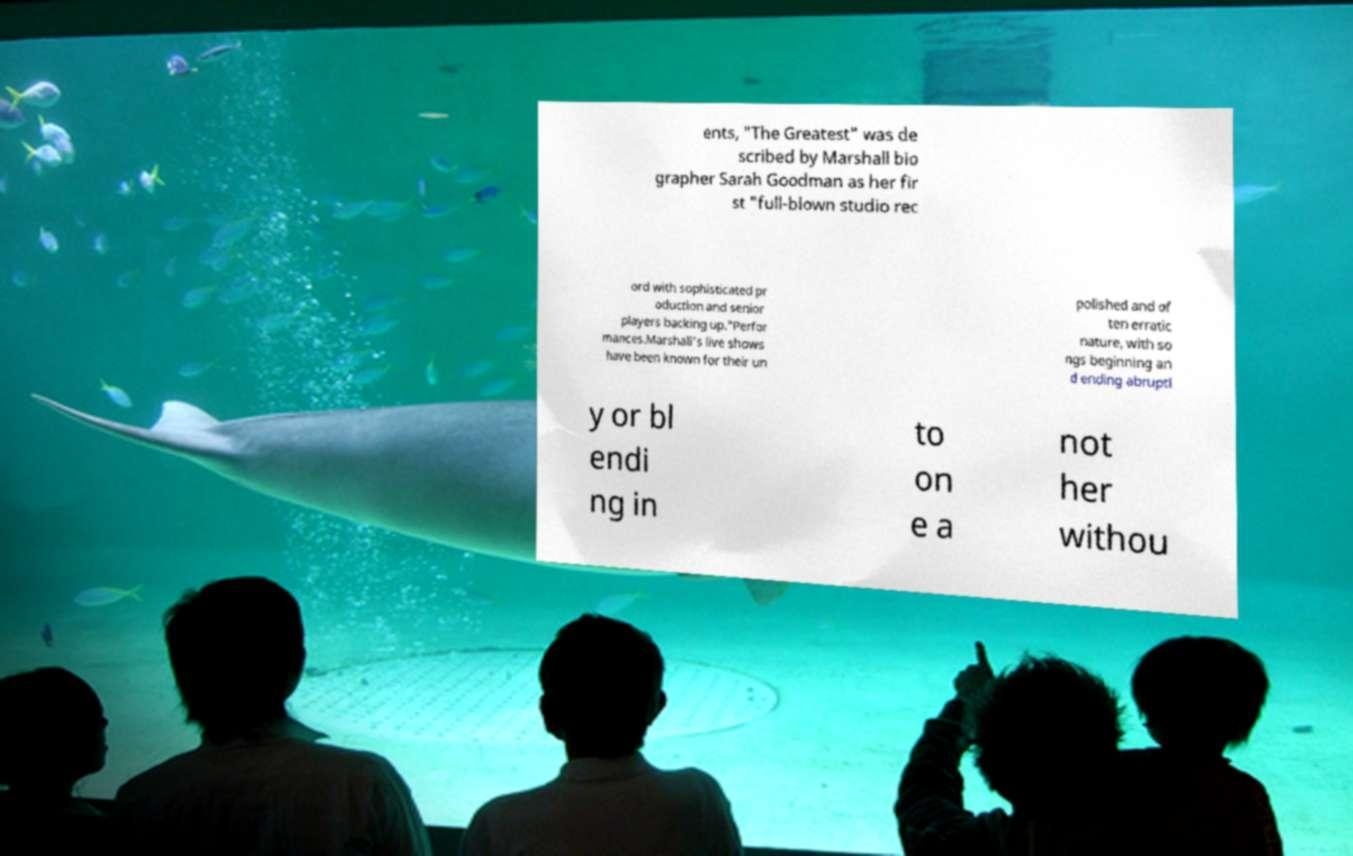Could you extract and type out the text from this image? ents, "The Greatest" was de scribed by Marshall bio grapher Sarah Goodman as her fir st "full-blown studio rec ord with sophisticated pr oduction and senior players backing up."Perfor mances.Marshall's live shows have been known for their un polished and of ten erratic nature, with so ngs beginning an d ending abruptl y or bl endi ng in to on e a not her withou 